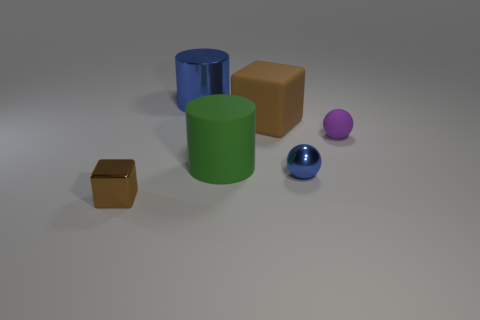Add 1 blue shiny cylinders. How many objects exist? 7 Subtract 1 cylinders. How many cylinders are left? 1 Subtract all yellow blocks. How many gray cylinders are left? 0 Subtract all purple spheres. Subtract all big rubber cubes. How many objects are left? 4 Add 3 shiny balls. How many shiny balls are left? 4 Add 4 brown rubber objects. How many brown rubber objects exist? 5 Subtract all blue cylinders. How many cylinders are left? 1 Subtract 0 purple cylinders. How many objects are left? 6 Subtract all cylinders. How many objects are left? 4 Subtract all gray cylinders. Subtract all blue blocks. How many cylinders are left? 2 